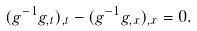Convert formula to latex. <formula><loc_0><loc_0><loc_500><loc_500>( g ^ { - 1 } g _ { , t } ) _ { , t } - ( g ^ { - 1 } g _ { , x } ) _ { , x } = 0 .</formula> 